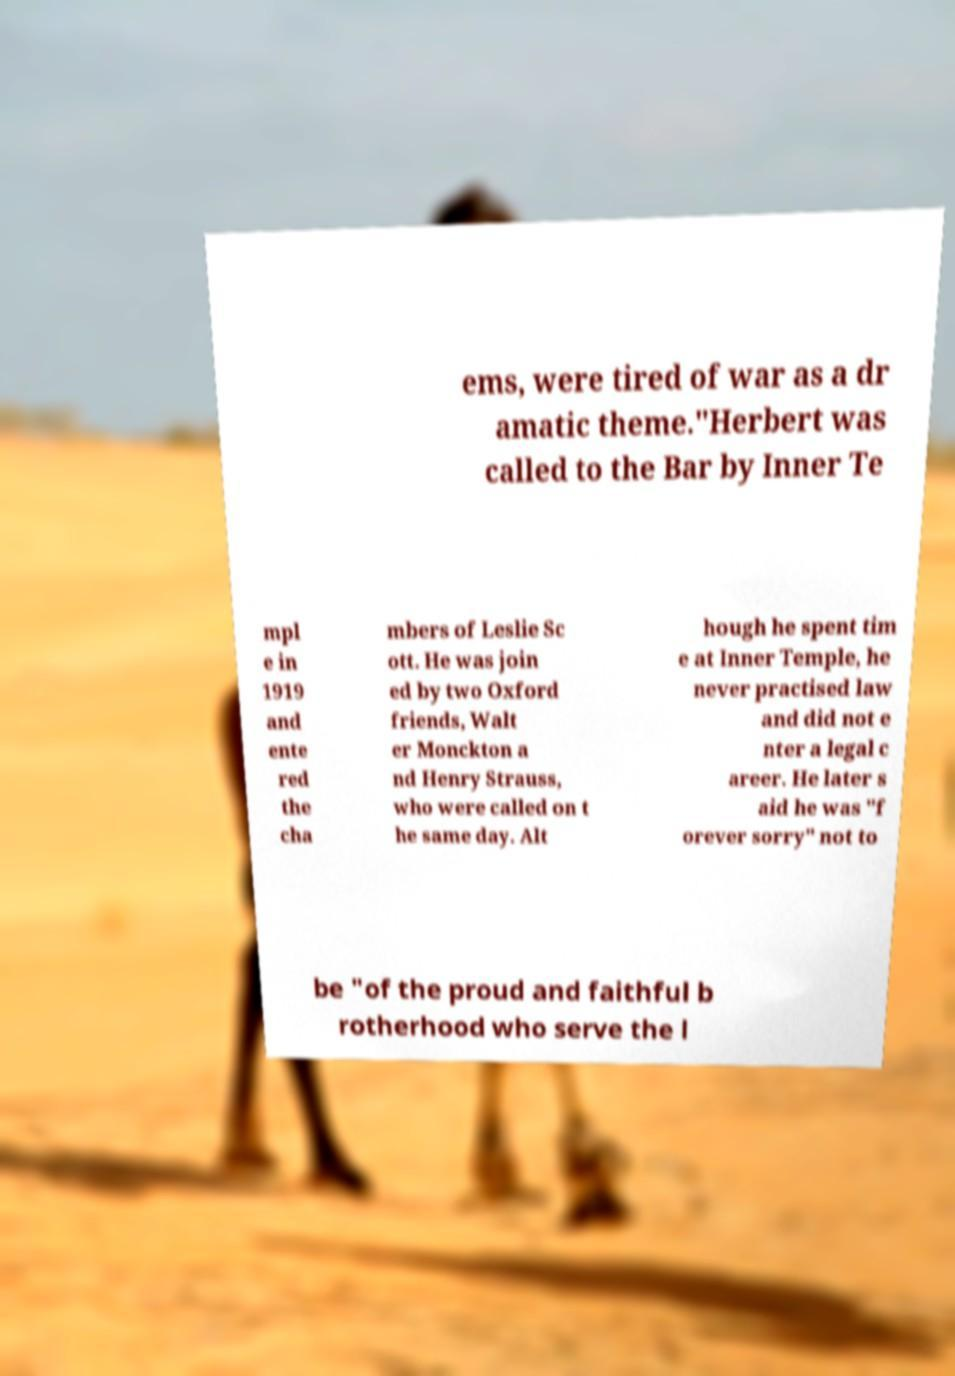Can you read and provide the text displayed in the image?This photo seems to have some interesting text. Can you extract and type it out for me? ems, were tired of war as a dr amatic theme."Herbert was called to the Bar by Inner Te mpl e in 1919 and ente red the cha mbers of Leslie Sc ott. He was join ed by two Oxford friends, Walt er Monckton a nd Henry Strauss, who were called on t he same day. Alt hough he spent tim e at Inner Temple, he never practised law and did not e nter a legal c areer. He later s aid he was "f orever sorry" not to be "of the proud and faithful b rotherhood who serve the l 